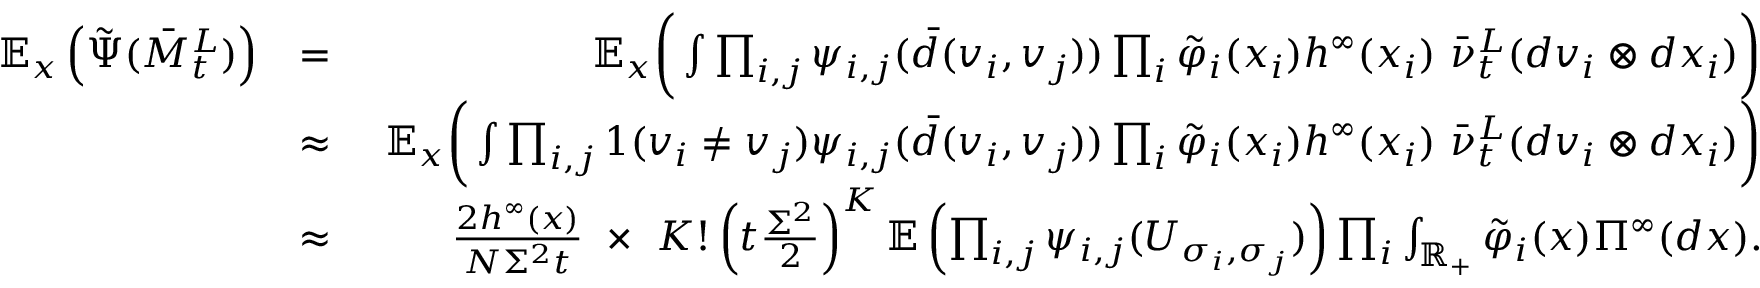<formula> <loc_0><loc_0><loc_500><loc_500>\begin{array} { r l r } { { \mathbb { E } } _ { x } \left ( \tilde { \Psi } ( \bar { M } _ { t } ^ { L } ) \right ) } & { = } & { \ \mathbb { E } _ { x } \left ( \int \prod _ { i , j } \psi _ { i , j } ( \bar { d } ( { v _ { i } , v _ { j } } ) ) \prod _ { i } \tilde { \varphi } _ { i } ( x _ { i } ) h ^ { \infty } ( x _ { i } ) \ \bar { \nu } _ { t } ^ { L } ( d v _ { i } \otimes d x _ { i } ) \right ) } \\ & { \approx } & { \ \mathbb { E } _ { x } \left ( \int \prod _ { i , j } 1 ( v _ { i } \neq v _ { j } ) \psi _ { i , j } ( \bar { d } ( { v _ { i } , v _ { j } } ) ) \prod _ { i } \tilde { \varphi } _ { i } ( x _ { i } ) h ^ { \infty } ( x _ { i } ) \ \bar { \nu } _ { t } ^ { L } ( d v _ { i } \otimes d x _ { i } ) \right ) } \\ & { \approx } & { \frac { 2 h ^ { \infty } ( x ) } { N \Sigma ^ { 2 } t } \ \times \ K ! \left ( t \frac { \Sigma ^ { 2 } } { 2 } \right ) ^ { K } { \mathbb { E } } \left ( \prod _ { i , j } \psi _ { i , j } ( U _ { \sigma _ { i } , \sigma _ { j } } ) \right ) \prod _ { i } \int _ { { \mathbb { R } } _ { + } } \tilde { \varphi } _ { i } ( x ) \Pi ^ { \infty } ( d x ) . } \end{array}</formula> 